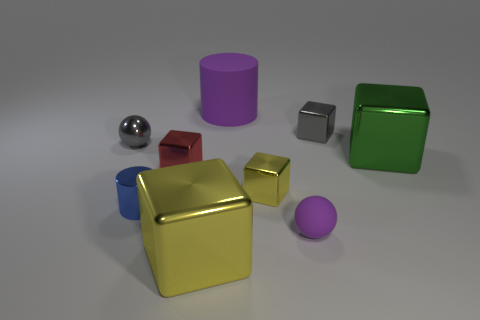There is a rubber cylinder; is it the same color as the ball in front of the green metallic thing?
Provide a succinct answer. Yes. There is a gray metal object that is behind the small metallic sphere; is it the same shape as the shiny object that is in front of the small blue metal object?
Your response must be concise. Yes. What is the size of the cylinder that is the same color as the tiny rubber object?
Your answer should be very brief. Large. Is there a tiny thing of the same color as the big cylinder?
Offer a terse response. Yes. There is a rubber object in front of the small gray metallic cube; how many big cubes are left of it?
Keep it short and to the point. 1. What number of things are either objects in front of the purple cylinder or large yellow metallic things?
Offer a very short reply. 8. How many small cylinders are the same material as the large yellow thing?
Make the answer very short. 1. The matte object that is the same color as the large matte cylinder is what shape?
Provide a short and direct response. Sphere. Are there an equal number of small purple matte spheres to the left of the large yellow object and metallic blocks?
Offer a very short reply. No. There is a purple matte thing that is behind the purple matte ball; how big is it?
Your answer should be compact. Large. 